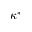Convert formula to latex. <formula><loc_0><loc_0><loc_500><loc_500>\kappa ^ { * }</formula> 